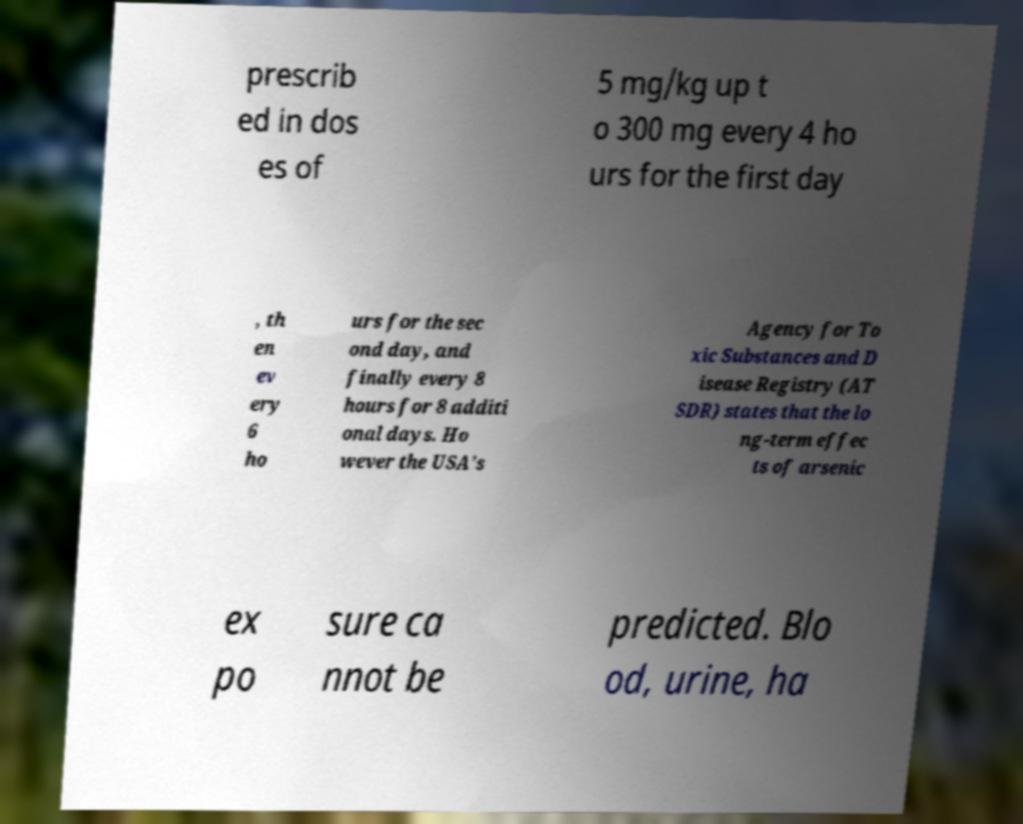I need the written content from this picture converted into text. Can you do that? prescrib ed in dos es of 5 mg/kg up t o 300 mg every 4 ho urs for the first day , th en ev ery 6 ho urs for the sec ond day, and finally every 8 hours for 8 additi onal days. Ho wever the USA's Agency for To xic Substances and D isease Registry (AT SDR) states that the lo ng-term effec ts of arsenic ex po sure ca nnot be predicted. Blo od, urine, ha 